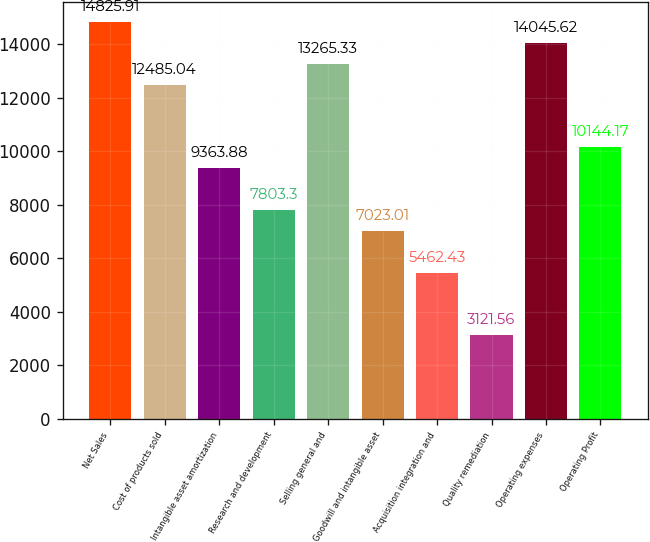<chart> <loc_0><loc_0><loc_500><loc_500><bar_chart><fcel>Net Sales<fcel>Cost of products sold<fcel>Intangible asset amortization<fcel>Research and development<fcel>Selling general and<fcel>Goodwill and intangible asset<fcel>Acquisition integration and<fcel>Quality remediation<fcel>Operating expenses<fcel>Operating Profit<nl><fcel>14825.9<fcel>12485<fcel>9363.88<fcel>7803.3<fcel>13265.3<fcel>7023.01<fcel>5462.43<fcel>3121.56<fcel>14045.6<fcel>10144.2<nl></chart> 